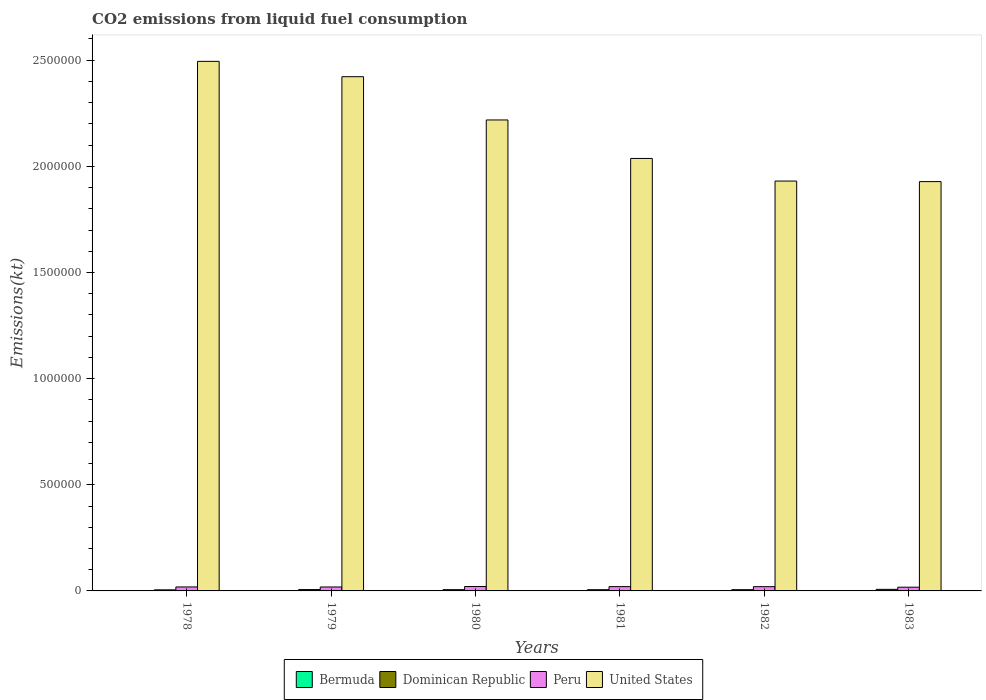How many groups of bars are there?
Offer a very short reply. 6. Are the number of bars per tick equal to the number of legend labels?
Keep it short and to the point. Yes. Are the number of bars on each tick of the X-axis equal?
Give a very brief answer. Yes. How many bars are there on the 2nd tick from the right?
Provide a short and direct response. 4. What is the amount of CO2 emitted in Dominican Republic in 1983?
Keep it short and to the point. 7363.34. Across all years, what is the maximum amount of CO2 emitted in United States?
Ensure brevity in your answer.  2.49e+06. Across all years, what is the minimum amount of CO2 emitted in Bermuda?
Offer a terse response. 388.7. In which year was the amount of CO2 emitted in United States maximum?
Make the answer very short. 1978. In which year was the amount of CO2 emitted in Dominican Republic minimum?
Ensure brevity in your answer.  1978. What is the total amount of CO2 emitted in United States in the graph?
Your answer should be very brief. 1.30e+07. What is the difference between the amount of CO2 emitted in Dominican Republic in 1978 and that in 1983?
Offer a very short reply. -2346.88. What is the difference between the amount of CO2 emitted in Dominican Republic in 1978 and the amount of CO2 emitted in Peru in 1980?
Your answer should be very brief. -1.57e+04. What is the average amount of CO2 emitted in Peru per year?
Offer a terse response. 1.93e+04. In the year 1983, what is the difference between the amount of CO2 emitted in Peru and amount of CO2 emitted in Bermuda?
Provide a short and direct response. 1.71e+04. In how many years, is the amount of CO2 emitted in Dominican Republic greater than 1800000 kt?
Offer a very short reply. 0. What is the ratio of the amount of CO2 emitted in Bermuda in 1980 to that in 1983?
Provide a succinct answer. 0.97. Is the amount of CO2 emitted in United States in 1979 less than that in 1981?
Ensure brevity in your answer.  No. What is the difference between the highest and the second highest amount of CO2 emitted in Bermuda?
Your answer should be compact. 11. What is the difference between the highest and the lowest amount of CO2 emitted in United States?
Offer a terse response. 5.66e+05. In how many years, is the amount of CO2 emitted in Peru greater than the average amount of CO2 emitted in Peru taken over all years?
Your answer should be very brief. 3. Is the sum of the amount of CO2 emitted in Peru in 1978 and 1980 greater than the maximum amount of CO2 emitted in Bermuda across all years?
Your response must be concise. Yes. Is it the case that in every year, the sum of the amount of CO2 emitted in Bermuda and amount of CO2 emitted in Peru is greater than the sum of amount of CO2 emitted in United States and amount of CO2 emitted in Dominican Republic?
Your answer should be very brief. Yes. What does the 4th bar from the left in 1983 represents?
Your answer should be very brief. United States. What does the 3rd bar from the right in 1979 represents?
Give a very brief answer. Dominican Republic. How many bars are there?
Give a very brief answer. 24. Does the graph contain any zero values?
Give a very brief answer. No. Does the graph contain grids?
Make the answer very short. No. Where does the legend appear in the graph?
Offer a very short reply. Bottom center. What is the title of the graph?
Offer a very short reply. CO2 emissions from liquid fuel consumption. Does "West Bank and Gaza" appear as one of the legend labels in the graph?
Give a very brief answer. No. What is the label or title of the X-axis?
Offer a very short reply. Years. What is the label or title of the Y-axis?
Your response must be concise. Emissions(kt). What is the Emissions(kt) in Bermuda in 1978?
Ensure brevity in your answer.  425.37. What is the Emissions(kt) of Dominican Republic in 1978?
Make the answer very short. 5016.46. What is the Emissions(kt) in Peru in 1978?
Provide a short and direct response. 1.87e+04. What is the Emissions(kt) of United States in 1978?
Ensure brevity in your answer.  2.49e+06. What is the Emissions(kt) of Bermuda in 1979?
Your response must be concise. 462.04. What is the Emissions(kt) in Dominican Republic in 1979?
Your answer should be compact. 6365.91. What is the Emissions(kt) of Peru in 1979?
Offer a terse response. 1.86e+04. What is the Emissions(kt) in United States in 1979?
Your answer should be very brief. 2.42e+06. What is the Emissions(kt) of Bermuda in 1980?
Your answer should be very brief. 436.37. What is the Emissions(kt) in Dominican Republic in 1980?
Make the answer very short. 5951.54. What is the Emissions(kt) in Peru in 1980?
Give a very brief answer. 2.07e+04. What is the Emissions(kt) of United States in 1980?
Give a very brief answer. 2.22e+06. What is the Emissions(kt) of Bermuda in 1981?
Provide a succinct answer. 388.7. What is the Emissions(kt) of Dominican Republic in 1981?
Your answer should be very brief. 5694.85. What is the Emissions(kt) of Peru in 1981?
Ensure brevity in your answer.  2.02e+04. What is the Emissions(kt) of United States in 1981?
Provide a succinct answer. 2.04e+06. What is the Emissions(kt) of Bermuda in 1982?
Offer a very short reply. 396.04. What is the Emissions(kt) in Dominican Republic in 1982?
Your response must be concise. 5867.2. What is the Emissions(kt) in Peru in 1982?
Give a very brief answer. 2.01e+04. What is the Emissions(kt) of United States in 1982?
Your response must be concise. 1.93e+06. What is the Emissions(kt) in Bermuda in 1983?
Offer a very short reply. 451.04. What is the Emissions(kt) of Dominican Republic in 1983?
Provide a short and direct response. 7363.34. What is the Emissions(kt) of Peru in 1983?
Provide a succinct answer. 1.76e+04. What is the Emissions(kt) in United States in 1983?
Provide a short and direct response. 1.93e+06. Across all years, what is the maximum Emissions(kt) in Bermuda?
Make the answer very short. 462.04. Across all years, what is the maximum Emissions(kt) of Dominican Republic?
Give a very brief answer. 7363.34. Across all years, what is the maximum Emissions(kt) in Peru?
Your response must be concise. 2.07e+04. Across all years, what is the maximum Emissions(kt) in United States?
Your answer should be very brief. 2.49e+06. Across all years, what is the minimum Emissions(kt) in Bermuda?
Your answer should be very brief. 388.7. Across all years, what is the minimum Emissions(kt) of Dominican Republic?
Offer a very short reply. 5016.46. Across all years, what is the minimum Emissions(kt) of Peru?
Ensure brevity in your answer.  1.76e+04. Across all years, what is the minimum Emissions(kt) of United States?
Your answer should be compact. 1.93e+06. What is the total Emissions(kt) of Bermuda in the graph?
Your answer should be compact. 2559.57. What is the total Emissions(kt) in Dominican Republic in the graph?
Make the answer very short. 3.63e+04. What is the total Emissions(kt) of Peru in the graph?
Your response must be concise. 1.16e+05. What is the total Emissions(kt) in United States in the graph?
Make the answer very short. 1.30e+07. What is the difference between the Emissions(kt) of Bermuda in 1978 and that in 1979?
Offer a very short reply. -36.67. What is the difference between the Emissions(kt) of Dominican Republic in 1978 and that in 1979?
Your response must be concise. -1349.46. What is the difference between the Emissions(kt) in Peru in 1978 and that in 1979?
Give a very brief answer. 172.35. What is the difference between the Emissions(kt) in United States in 1978 and that in 1979?
Provide a short and direct response. 7.23e+04. What is the difference between the Emissions(kt) in Bermuda in 1978 and that in 1980?
Offer a very short reply. -11. What is the difference between the Emissions(kt) in Dominican Republic in 1978 and that in 1980?
Make the answer very short. -935.09. What is the difference between the Emissions(kt) of Peru in 1978 and that in 1980?
Make the answer very short. -1972.85. What is the difference between the Emissions(kt) of United States in 1978 and that in 1980?
Ensure brevity in your answer.  2.76e+05. What is the difference between the Emissions(kt) of Bermuda in 1978 and that in 1981?
Provide a succinct answer. 36.67. What is the difference between the Emissions(kt) of Dominican Republic in 1978 and that in 1981?
Provide a short and direct response. -678.39. What is the difference between the Emissions(kt) of Peru in 1978 and that in 1981?
Keep it short and to the point. -1507.14. What is the difference between the Emissions(kt) of United States in 1978 and that in 1981?
Give a very brief answer. 4.57e+05. What is the difference between the Emissions(kt) in Bermuda in 1978 and that in 1982?
Provide a succinct answer. 29.34. What is the difference between the Emissions(kt) in Dominican Republic in 1978 and that in 1982?
Offer a terse response. -850.74. What is the difference between the Emissions(kt) of Peru in 1978 and that in 1982?
Your response must be concise. -1345.79. What is the difference between the Emissions(kt) of United States in 1978 and that in 1982?
Offer a very short reply. 5.64e+05. What is the difference between the Emissions(kt) of Bermuda in 1978 and that in 1983?
Provide a short and direct response. -25.67. What is the difference between the Emissions(kt) in Dominican Republic in 1978 and that in 1983?
Your answer should be compact. -2346.88. What is the difference between the Emissions(kt) in Peru in 1978 and that in 1983?
Your answer should be compact. 1166.11. What is the difference between the Emissions(kt) of United States in 1978 and that in 1983?
Provide a succinct answer. 5.66e+05. What is the difference between the Emissions(kt) in Bermuda in 1979 and that in 1980?
Keep it short and to the point. 25.67. What is the difference between the Emissions(kt) of Dominican Republic in 1979 and that in 1980?
Offer a very short reply. 414.37. What is the difference between the Emissions(kt) of Peru in 1979 and that in 1980?
Provide a succinct answer. -2145.2. What is the difference between the Emissions(kt) of United States in 1979 and that in 1980?
Ensure brevity in your answer.  2.04e+05. What is the difference between the Emissions(kt) in Bermuda in 1979 and that in 1981?
Keep it short and to the point. 73.34. What is the difference between the Emissions(kt) of Dominican Republic in 1979 and that in 1981?
Keep it short and to the point. 671.06. What is the difference between the Emissions(kt) of Peru in 1979 and that in 1981?
Make the answer very short. -1679.49. What is the difference between the Emissions(kt) of United States in 1979 and that in 1981?
Offer a very short reply. 3.85e+05. What is the difference between the Emissions(kt) in Bermuda in 1979 and that in 1982?
Offer a terse response. 66.01. What is the difference between the Emissions(kt) of Dominican Republic in 1979 and that in 1982?
Your answer should be very brief. 498.71. What is the difference between the Emissions(kt) in Peru in 1979 and that in 1982?
Ensure brevity in your answer.  -1518.14. What is the difference between the Emissions(kt) of United States in 1979 and that in 1982?
Your answer should be very brief. 4.92e+05. What is the difference between the Emissions(kt) of Bermuda in 1979 and that in 1983?
Offer a terse response. 11. What is the difference between the Emissions(kt) in Dominican Republic in 1979 and that in 1983?
Give a very brief answer. -997.42. What is the difference between the Emissions(kt) of Peru in 1979 and that in 1983?
Provide a succinct answer. 993.76. What is the difference between the Emissions(kt) of United States in 1979 and that in 1983?
Your response must be concise. 4.94e+05. What is the difference between the Emissions(kt) in Bermuda in 1980 and that in 1981?
Provide a succinct answer. 47.67. What is the difference between the Emissions(kt) in Dominican Republic in 1980 and that in 1981?
Your response must be concise. 256.69. What is the difference between the Emissions(kt) in Peru in 1980 and that in 1981?
Provide a succinct answer. 465.71. What is the difference between the Emissions(kt) in United States in 1980 and that in 1981?
Offer a terse response. 1.81e+05. What is the difference between the Emissions(kt) in Bermuda in 1980 and that in 1982?
Your response must be concise. 40.34. What is the difference between the Emissions(kt) of Dominican Republic in 1980 and that in 1982?
Ensure brevity in your answer.  84.34. What is the difference between the Emissions(kt) in Peru in 1980 and that in 1982?
Give a very brief answer. 627.06. What is the difference between the Emissions(kt) of United States in 1980 and that in 1982?
Your response must be concise. 2.88e+05. What is the difference between the Emissions(kt) in Bermuda in 1980 and that in 1983?
Ensure brevity in your answer.  -14.67. What is the difference between the Emissions(kt) of Dominican Republic in 1980 and that in 1983?
Ensure brevity in your answer.  -1411.8. What is the difference between the Emissions(kt) of Peru in 1980 and that in 1983?
Offer a very short reply. 3138.95. What is the difference between the Emissions(kt) in United States in 1980 and that in 1983?
Your response must be concise. 2.90e+05. What is the difference between the Emissions(kt) in Bermuda in 1981 and that in 1982?
Offer a very short reply. -7.33. What is the difference between the Emissions(kt) in Dominican Republic in 1981 and that in 1982?
Your response must be concise. -172.35. What is the difference between the Emissions(kt) of Peru in 1981 and that in 1982?
Your response must be concise. 161.35. What is the difference between the Emissions(kt) of United States in 1981 and that in 1982?
Make the answer very short. 1.07e+05. What is the difference between the Emissions(kt) of Bermuda in 1981 and that in 1983?
Offer a very short reply. -62.34. What is the difference between the Emissions(kt) of Dominican Republic in 1981 and that in 1983?
Your answer should be very brief. -1668.48. What is the difference between the Emissions(kt) of Peru in 1981 and that in 1983?
Make the answer very short. 2673.24. What is the difference between the Emissions(kt) of United States in 1981 and that in 1983?
Your response must be concise. 1.09e+05. What is the difference between the Emissions(kt) in Bermuda in 1982 and that in 1983?
Provide a short and direct response. -55.01. What is the difference between the Emissions(kt) of Dominican Republic in 1982 and that in 1983?
Ensure brevity in your answer.  -1496.14. What is the difference between the Emissions(kt) in Peru in 1982 and that in 1983?
Make the answer very short. 2511.89. What is the difference between the Emissions(kt) in United States in 1982 and that in 1983?
Provide a succinct answer. 2511.89. What is the difference between the Emissions(kt) in Bermuda in 1978 and the Emissions(kt) in Dominican Republic in 1979?
Your answer should be very brief. -5940.54. What is the difference between the Emissions(kt) in Bermuda in 1978 and the Emissions(kt) in Peru in 1979?
Provide a succinct answer. -1.81e+04. What is the difference between the Emissions(kt) of Bermuda in 1978 and the Emissions(kt) of United States in 1979?
Your response must be concise. -2.42e+06. What is the difference between the Emissions(kt) in Dominican Republic in 1978 and the Emissions(kt) in Peru in 1979?
Keep it short and to the point. -1.36e+04. What is the difference between the Emissions(kt) of Dominican Republic in 1978 and the Emissions(kt) of United States in 1979?
Ensure brevity in your answer.  -2.42e+06. What is the difference between the Emissions(kt) of Peru in 1978 and the Emissions(kt) of United States in 1979?
Make the answer very short. -2.40e+06. What is the difference between the Emissions(kt) of Bermuda in 1978 and the Emissions(kt) of Dominican Republic in 1980?
Offer a terse response. -5526.17. What is the difference between the Emissions(kt) of Bermuda in 1978 and the Emissions(kt) of Peru in 1980?
Your answer should be compact. -2.03e+04. What is the difference between the Emissions(kt) in Bermuda in 1978 and the Emissions(kt) in United States in 1980?
Provide a short and direct response. -2.22e+06. What is the difference between the Emissions(kt) in Dominican Republic in 1978 and the Emissions(kt) in Peru in 1980?
Your response must be concise. -1.57e+04. What is the difference between the Emissions(kt) in Dominican Republic in 1978 and the Emissions(kt) in United States in 1980?
Your answer should be very brief. -2.21e+06. What is the difference between the Emissions(kt) of Peru in 1978 and the Emissions(kt) of United States in 1980?
Make the answer very short. -2.20e+06. What is the difference between the Emissions(kt) in Bermuda in 1978 and the Emissions(kt) in Dominican Republic in 1981?
Provide a short and direct response. -5269.48. What is the difference between the Emissions(kt) of Bermuda in 1978 and the Emissions(kt) of Peru in 1981?
Your response must be concise. -1.98e+04. What is the difference between the Emissions(kt) in Bermuda in 1978 and the Emissions(kt) in United States in 1981?
Your answer should be very brief. -2.04e+06. What is the difference between the Emissions(kt) of Dominican Republic in 1978 and the Emissions(kt) of Peru in 1981?
Your answer should be compact. -1.52e+04. What is the difference between the Emissions(kt) in Dominican Republic in 1978 and the Emissions(kt) in United States in 1981?
Give a very brief answer. -2.03e+06. What is the difference between the Emissions(kt) in Peru in 1978 and the Emissions(kt) in United States in 1981?
Your answer should be compact. -2.02e+06. What is the difference between the Emissions(kt) in Bermuda in 1978 and the Emissions(kt) in Dominican Republic in 1982?
Your response must be concise. -5441.83. What is the difference between the Emissions(kt) in Bermuda in 1978 and the Emissions(kt) in Peru in 1982?
Ensure brevity in your answer.  -1.97e+04. What is the difference between the Emissions(kt) in Bermuda in 1978 and the Emissions(kt) in United States in 1982?
Offer a very short reply. -1.93e+06. What is the difference between the Emissions(kt) of Dominican Republic in 1978 and the Emissions(kt) of Peru in 1982?
Your answer should be very brief. -1.51e+04. What is the difference between the Emissions(kt) of Dominican Republic in 1978 and the Emissions(kt) of United States in 1982?
Keep it short and to the point. -1.93e+06. What is the difference between the Emissions(kt) in Peru in 1978 and the Emissions(kt) in United States in 1982?
Offer a terse response. -1.91e+06. What is the difference between the Emissions(kt) of Bermuda in 1978 and the Emissions(kt) of Dominican Republic in 1983?
Offer a very short reply. -6937.96. What is the difference between the Emissions(kt) of Bermuda in 1978 and the Emissions(kt) of Peru in 1983?
Provide a short and direct response. -1.72e+04. What is the difference between the Emissions(kt) in Bermuda in 1978 and the Emissions(kt) in United States in 1983?
Your response must be concise. -1.93e+06. What is the difference between the Emissions(kt) in Dominican Republic in 1978 and the Emissions(kt) in Peru in 1983?
Your response must be concise. -1.26e+04. What is the difference between the Emissions(kt) in Dominican Republic in 1978 and the Emissions(kt) in United States in 1983?
Your answer should be compact. -1.92e+06. What is the difference between the Emissions(kt) of Peru in 1978 and the Emissions(kt) of United States in 1983?
Give a very brief answer. -1.91e+06. What is the difference between the Emissions(kt) of Bermuda in 1979 and the Emissions(kt) of Dominican Republic in 1980?
Make the answer very short. -5489.5. What is the difference between the Emissions(kt) of Bermuda in 1979 and the Emissions(kt) of Peru in 1980?
Provide a succinct answer. -2.03e+04. What is the difference between the Emissions(kt) in Bermuda in 1979 and the Emissions(kt) in United States in 1980?
Provide a succinct answer. -2.22e+06. What is the difference between the Emissions(kt) of Dominican Republic in 1979 and the Emissions(kt) of Peru in 1980?
Provide a succinct answer. -1.43e+04. What is the difference between the Emissions(kt) of Dominican Republic in 1979 and the Emissions(kt) of United States in 1980?
Offer a very short reply. -2.21e+06. What is the difference between the Emissions(kt) in Peru in 1979 and the Emissions(kt) in United States in 1980?
Give a very brief answer. -2.20e+06. What is the difference between the Emissions(kt) of Bermuda in 1979 and the Emissions(kt) of Dominican Republic in 1981?
Offer a very short reply. -5232.81. What is the difference between the Emissions(kt) of Bermuda in 1979 and the Emissions(kt) of Peru in 1981?
Ensure brevity in your answer.  -1.98e+04. What is the difference between the Emissions(kt) of Bermuda in 1979 and the Emissions(kt) of United States in 1981?
Keep it short and to the point. -2.04e+06. What is the difference between the Emissions(kt) of Dominican Republic in 1979 and the Emissions(kt) of Peru in 1981?
Give a very brief answer. -1.39e+04. What is the difference between the Emissions(kt) in Dominican Republic in 1979 and the Emissions(kt) in United States in 1981?
Your answer should be very brief. -2.03e+06. What is the difference between the Emissions(kt) in Peru in 1979 and the Emissions(kt) in United States in 1981?
Your answer should be compact. -2.02e+06. What is the difference between the Emissions(kt) of Bermuda in 1979 and the Emissions(kt) of Dominican Republic in 1982?
Ensure brevity in your answer.  -5405.16. What is the difference between the Emissions(kt) in Bermuda in 1979 and the Emissions(kt) in Peru in 1982?
Your answer should be compact. -1.96e+04. What is the difference between the Emissions(kt) of Bermuda in 1979 and the Emissions(kt) of United States in 1982?
Your answer should be compact. -1.93e+06. What is the difference between the Emissions(kt) in Dominican Republic in 1979 and the Emissions(kt) in Peru in 1982?
Provide a short and direct response. -1.37e+04. What is the difference between the Emissions(kt) in Dominican Republic in 1979 and the Emissions(kt) in United States in 1982?
Keep it short and to the point. -1.92e+06. What is the difference between the Emissions(kt) of Peru in 1979 and the Emissions(kt) of United States in 1982?
Keep it short and to the point. -1.91e+06. What is the difference between the Emissions(kt) in Bermuda in 1979 and the Emissions(kt) in Dominican Republic in 1983?
Give a very brief answer. -6901.29. What is the difference between the Emissions(kt) in Bermuda in 1979 and the Emissions(kt) in Peru in 1983?
Give a very brief answer. -1.71e+04. What is the difference between the Emissions(kt) of Bermuda in 1979 and the Emissions(kt) of United States in 1983?
Provide a succinct answer. -1.93e+06. What is the difference between the Emissions(kt) of Dominican Republic in 1979 and the Emissions(kt) of Peru in 1983?
Offer a terse response. -1.12e+04. What is the difference between the Emissions(kt) of Dominican Republic in 1979 and the Emissions(kt) of United States in 1983?
Offer a very short reply. -1.92e+06. What is the difference between the Emissions(kt) in Peru in 1979 and the Emissions(kt) in United States in 1983?
Make the answer very short. -1.91e+06. What is the difference between the Emissions(kt) of Bermuda in 1980 and the Emissions(kt) of Dominican Republic in 1981?
Offer a terse response. -5258.48. What is the difference between the Emissions(kt) of Bermuda in 1980 and the Emissions(kt) of Peru in 1981?
Offer a terse response. -1.98e+04. What is the difference between the Emissions(kt) of Bermuda in 1980 and the Emissions(kt) of United States in 1981?
Make the answer very short. -2.04e+06. What is the difference between the Emissions(kt) of Dominican Republic in 1980 and the Emissions(kt) of Peru in 1981?
Provide a succinct answer. -1.43e+04. What is the difference between the Emissions(kt) of Dominican Republic in 1980 and the Emissions(kt) of United States in 1981?
Give a very brief answer. -2.03e+06. What is the difference between the Emissions(kt) in Peru in 1980 and the Emissions(kt) in United States in 1981?
Give a very brief answer. -2.02e+06. What is the difference between the Emissions(kt) in Bermuda in 1980 and the Emissions(kt) in Dominican Republic in 1982?
Make the answer very short. -5430.83. What is the difference between the Emissions(kt) of Bermuda in 1980 and the Emissions(kt) of Peru in 1982?
Give a very brief answer. -1.97e+04. What is the difference between the Emissions(kt) of Bermuda in 1980 and the Emissions(kt) of United States in 1982?
Give a very brief answer. -1.93e+06. What is the difference between the Emissions(kt) in Dominican Republic in 1980 and the Emissions(kt) in Peru in 1982?
Your answer should be very brief. -1.41e+04. What is the difference between the Emissions(kt) of Dominican Republic in 1980 and the Emissions(kt) of United States in 1982?
Your answer should be compact. -1.92e+06. What is the difference between the Emissions(kt) in Peru in 1980 and the Emissions(kt) in United States in 1982?
Keep it short and to the point. -1.91e+06. What is the difference between the Emissions(kt) of Bermuda in 1980 and the Emissions(kt) of Dominican Republic in 1983?
Ensure brevity in your answer.  -6926.96. What is the difference between the Emissions(kt) in Bermuda in 1980 and the Emissions(kt) in Peru in 1983?
Your answer should be very brief. -1.71e+04. What is the difference between the Emissions(kt) in Bermuda in 1980 and the Emissions(kt) in United States in 1983?
Your answer should be compact. -1.93e+06. What is the difference between the Emissions(kt) of Dominican Republic in 1980 and the Emissions(kt) of Peru in 1983?
Ensure brevity in your answer.  -1.16e+04. What is the difference between the Emissions(kt) in Dominican Republic in 1980 and the Emissions(kt) in United States in 1983?
Your answer should be compact. -1.92e+06. What is the difference between the Emissions(kt) of Peru in 1980 and the Emissions(kt) of United States in 1983?
Keep it short and to the point. -1.91e+06. What is the difference between the Emissions(kt) of Bermuda in 1981 and the Emissions(kt) of Dominican Republic in 1982?
Provide a succinct answer. -5478.5. What is the difference between the Emissions(kt) in Bermuda in 1981 and the Emissions(kt) in Peru in 1982?
Offer a terse response. -1.97e+04. What is the difference between the Emissions(kt) of Bermuda in 1981 and the Emissions(kt) of United States in 1982?
Provide a short and direct response. -1.93e+06. What is the difference between the Emissions(kt) in Dominican Republic in 1981 and the Emissions(kt) in Peru in 1982?
Your answer should be compact. -1.44e+04. What is the difference between the Emissions(kt) of Dominican Republic in 1981 and the Emissions(kt) of United States in 1982?
Make the answer very short. -1.93e+06. What is the difference between the Emissions(kt) in Peru in 1981 and the Emissions(kt) in United States in 1982?
Ensure brevity in your answer.  -1.91e+06. What is the difference between the Emissions(kt) in Bermuda in 1981 and the Emissions(kt) in Dominican Republic in 1983?
Your response must be concise. -6974.63. What is the difference between the Emissions(kt) of Bermuda in 1981 and the Emissions(kt) of Peru in 1983?
Ensure brevity in your answer.  -1.72e+04. What is the difference between the Emissions(kt) in Bermuda in 1981 and the Emissions(kt) in United States in 1983?
Keep it short and to the point. -1.93e+06. What is the difference between the Emissions(kt) of Dominican Republic in 1981 and the Emissions(kt) of Peru in 1983?
Provide a short and direct response. -1.19e+04. What is the difference between the Emissions(kt) in Dominican Republic in 1981 and the Emissions(kt) in United States in 1983?
Your response must be concise. -1.92e+06. What is the difference between the Emissions(kt) of Peru in 1981 and the Emissions(kt) of United States in 1983?
Make the answer very short. -1.91e+06. What is the difference between the Emissions(kt) in Bermuda in 1982 and the Emissions(kt) in Dominican Republic in 1983?
Your answer should be compact. -6967.3. What is the difference between the Emissions(kt) in Bermuda in 1982 and the Emissions(kt) in Peru in 1983?
Provide a short and direct response. -1.72e+04. What is the difference between the Emissions(kt) of Bermuda in 1982 and the Emissions(kt) of United States in 1983?
Provide a succinct answer. -1.93e+06. What is the difference between the Emissions(kt) of Dominican Republic in 1982 and the Emissions(kt) of Peru in 1983?
Ensure brevity in your answer.  -1.17e+04. What is the difference between the Emissions(kt) in Dominican Republic in 1982 and the Emissions(kt) in United States in 1983?
Your answer should be very brief. -1.92e+06. What is the difference between the Emissions(kt) of Peru in 1982 and the Emissions(kt) of United States in 1983?
Offer a terse response. -1.91e+06. What is the average Emissions(kt) in Bermuda per year?
Your answer should be compact. 426.59. What is the average Emissions(kt) in Dominican Republic per year?
Offer a terse response. 6043.22. What is the average Emissions(kt) in Peru per year?
Offer a terse response. 1.93e+04. What is the average Emissions(kt) of United States per year?
Offer a terse response. 2.17e+06. In the year 1978, what is the difference between the Emissions(kt) in Bermuda and Emissions(kt) in Dominican Republic?
Offer a terse response. -4591.08. In the year 1978, what is the difference between the Emissions(kt) of Bermuda and Emissions(kt) of Peru?
Offer a very short reply. -1.83e+04. In the year 1978, what is the difference between the Emissions(kt) in Bermuda and Emissions(kt) in United States?
Provide a succinct answer. -2.49e+06. In the year 1978, what is the difference between the Emissions(kt) in Dominican Republic and Emissions(kt) in Peru?
Provide a succinct answer. -1.37e+04. In the year 1978, what is the difference between the Emissions(kt) of Dominican Republic and Emissions(kt) of United States?
Provide a short and direct response. -2.49e+06. In the year 1978, what is the difference between the Emissions(kt) of Peru and Emissions(kt) of United States?
Give a very brief answer. -2.48e+06. In the year 1979, what is the difference between the Emissions(kt) of Bermuda and Emissions(kt) of Dominican Republic?
Offer a terse response. -5903.87. In the year 1979, what is the difference between the Emissions(kt) in Bermuda and Emissions(kt) in Peru?
Your response must be concise. -1.81e+04. In the year 1979, what is the difference between the Emissions(kt) in Bermuda and Emissions(kt) in United States?
Your response must be concise. -2.42e+06. In the year 1979, what is the difference between the Emissions(kt) in Dominican Republic and Emissions(kt) in Peru?
Your response must be concise. -1.22e+04. In the year 1979, what is the difference between the Emissions(kt) of Dominican Republic and Emissions(kt) of United States?
Your response must be concise. -2.42e+06. In the year 1979, what is the difference between the Emissions(kt) of Peru and Emissions(kt) of United States?
Provide a short and direct response. -2.40e+06. In the year 1980, what is the difference between the Emissions(kt) in Bermuda and Emissions(kt) in Dominican Republic?
Offer a terse response. -5515.17. In the year 1980, what is the difference between the Emissions(kt) in Bermuda and Emissions(kt) in Peru?
Keep it short and to the point. -2.03e+04. In the year 1980, what is the difference between the Emissions(kt) in Bermuda and Emissions(kt) in United States?
Make the answer very short. -2.22e+06. In the year 1980, what is the difference between the Emissions(kt) of Dominican Republic and Emissions(kt) of Peru?
Offer a terse response. -1.48e+04. In the year 1980, what is the difference between the Emissions(kt) of Dominican Republic and Emissions(kt) of United States?
Give a very brief answer. -2.21e+06. In the year 1980, what is the difference between the Emissions(kt) in Peru and Emissions(kt) in United States?
Provide a short and direct response. -2.20e+06. In the year 1981, what is the difference between the Emissions(kt) in Bermuda and Emissions(kt) in Dominican Republic?
Give a very brief answer. -5306.15. In the year 1981, what is the difference between the Emissions(kt) in Bermuda and Emissions(kt) in Peru?
Ensure brevity in your answer.  -1.99e+04. In the year 1981, what is the difference between the Emissions(kt) of Bermuda and Emissions(kt) of United States?
Provide a short and direct response. -2.04e+06. In the year 1981, what is the difference between the Emissions(kt) in Dominican Republic and Emissions(kt) in Peru?
Ensure brevity in your answer.  -1.46e+04. In the year 1981, what is the difference between the Emissions(kt) in Dominican Republic and Emissions(kt) in United States?
Make the answer very short. -2.03e+06. In the year 1981, what is the difference between the Emissions(kt) of Peru and Emissions(kt) of United States?
Ensure brevity in your answer.  -2.02e+06. In the year 1982, what is the difference between the Emissions(kt) in Bermuda and Emissions(kt) in Dominican Republic?
Give a very brief answer. -5471.16. In the year 1982, what is the difference between the Emissions(kt) of Bermuda and Emissions(kt) of Peru?
Your response must be concise. -1.97e+04. In the year 1982, what is the difference between the Emissions(kt) of Bermuda and Emissions(kt) of United States?
Offer a very short reply. -1.93e+06. In the year 1982, what is the difference between the Emissions(kt) in Dominican Republic and Emissions(kt) in Peru?
Offer a terse response. -1.42e+04. In the year 1982, what is the difference between the Emissions(kt) in Dominican Republic and Emissions(kt) in United States?
Give a very brief answer. -1.92e+06. In the year 1982, what is the difference between the Emissions(kt) in Peru and Emissions(kt) in United States?
Provide a short and direct response. -1.91e+06. In the year 1983, what is the difference between the Emissions(kt) of Bermuda and Emissions(kt) of Dominican Republic?
Provide a short and direct response. -6912.3. In the year 1983, what is the difference between the Emissions(kt) of Bermuda and Emissions(kt) of Peru?
Your response must be concise. -1.71e+04. In the year 1983, what is the difference between the Emissions(kt) in Bermuda and Emissions(kt) in United States?
Your response must be concise. -1.93e+06. In the year 1983, what is the difference between the Emissions(kt) of Dominican Republic and Emissions(kt) of Peru?
Give a very brief answer. -1.02e+04. In the year 1983, what is the difference between the Emissions(kt) in Dominican Republic and Emissions(kt) in United States?
Give a very brief answer. -1.92e+06. In the year 1983, what is the difference between the Emissions(kt) in Peru and Emissions(kt) in United States?
Make the answer very short. -1.91e+06. What is the ratio of the Emissions(kt) in Bermuda in 1978 to that in 1979?
Provide a succinct answer. 0.92. What is the ratio of the Emissions(kt) in Dominican Republic in 1978 to that in 1979?
Give a very brief answer. 0.79. What is the ratio of the Emissions(kt) in Peru in 1978 to that in 1979?
Ensure brevity in your answer.  1.01. What is the ratio of the Emissions(kt) in United States in 1978 to that in 1979?
Your answer should be very brief. 1.03. What is the ratio of the Emissions(kt) of Bermuda in 1978 to that in 1980?
Make the answer very short. 0.97. What is the ratio of the Emissions(kt) in Dominican Republic in 1978 to that in 1980?
Offer a terse response. 0.84. What is the ratio of the Emissions(kt) in Peru in 1978 to that in 1980?
Ensure brevity in your answer.  0.9. What is the ratio of the Emissions(kt) of United States in 1978 to that in 1980?
Provide a succinct answer. 1.12. What is the ratio of the Emissions(kt) in Bermuda in 1978 to that in 1981?
Provide a short and direct response. 1.09. What is the ratio of the Emissions(kt) in Dominican Republic in 1978 to that in 1981?
Offer a terse response. 0.88. What is the ratio of the Emissions(kt) of Peru in 1978 to that in 1981?
Give a very brief answer. 0.93. What is the ratio of the Emissions(kt) in United States in 1978 to that in 1981?
Make the answer very short. 1.22. What is the ratio of the Emissions(kt) of Bermuda in 1978 to that in 1982?
Your answer should be very brief. 1.07. What is the ratio of the Emissions(kt) of Dominican Republic in 1978 to that in 1982?
Your answer should be very brief. 0.85. What is the ratio of the Emissions(kt) of Peru in 1978 to that in 1982?
Give a very brief answer. 0.93. What is the ratio of the Emissions(kt) of United States in 1978 to that in 1982?
Make the answer very short. 1.29. What is the ratio of the Emissions(kt) in Bermuda in 1978 to that in 1983?
Your answer should be compact. 0.94. What is the ratio of the Emissions(kt) in Dominican Republic in 1978 to that in 1983?
Ensure brevity in your answer.  0.68. What is the ratio of the Emissions(kt) in Peru in 1978 to that in 1983?
Keep it short and to the point. 1.07. What is the ratio of the Emissions(kt) in United States in 1978 to that in 1983?
Your response must be concise. 1.29. What is the ratio of the Emissions(kt) in Bermuda in 1979 to that in 1980?
Give a very brief answer. 1.06. What is the ratio of the Emissions(kt) in Dominican Republic in 1979 to that in 1980?
Provide a succinct answer. 1.07. What is the ratio of the Emissions(kt) of Peru in 1979 to that in 1980?
Give a very brief answer. 0.9. What is the ratio of the Emissions(kt) of United States in 1979 to that in 1980?
Offer a terse response. 1.09. What is the ratio of the Emissions(kt) of Bermuda in 1979 to that in 1981?
Your response must be concise. 1.19. What is the ratio of the Emissions(kt) in Dominican Republic in 1979 to that in 1981?
Provide a short and direct response. 1.12. What is the ratio of the Emissions(kt) of Peru in 1979 to that in 1981?
Make the answer very short. 0.92. What is the ratio of the Emissions(kt) in United States in 1979 to that in 1981?
Provide a succinct answer. 1.19. What is the ratio of the Emissions(kt) in Bermuda in 1979 to that in 1982?
Keep it short and to the point. 1.17. What is the ratio of the Emissions(kt) in Dominican Republic in 1979 to that in 1982?
Your answer should be very brief. 1.08. What is the ratio of the Emissions(kt) of Peru in 1979 to that in 1982?
Provide a succinct answer. 0.92. What is the ratio of the Emissions(kt) of United States in 1979 to that in 1982?
Your answer should be very brief. 1.25. What is the ratio of the Emissions(kt) of Bermuda in 1979 to that in 1983?
Ensure brevity in your answer.  1.02. What is the ratio of the Emissions(kt) in Dominican Republic in 1979 to that in 1983?
Give a very brief answer. 0.86. What is the ratio of the Emissions(kt) in Peru in 1979 to that in 1983?
Give a very brief answer. 1.06. What is the ratio of the Emissions(kt) in United States in 1979 to that in 1983?
Offer a terse response. 1.26. What is the ratio of the Emissions(kt) in Bermuda in 1980 to that in 1981?
Your response must be concise. 1.12. What is the ratio of the Emissions(kt) in Dominican Republic in 1980 to that in 1981?
Provide a short and direct response. 1.05. What is the ratio of the Emissions(kt) of United States in 1980 to that in 1981?
Provide a short and direct response. 1.09. What is the ratio of the Emissions(kt) in Bermuda in 1980 to that in 1982?
Ensure brevity in your answer.  1.1. What is the ratio of the Emissions(kt) in Dominican Republic in 1980 to that in 1982?
Offer a very short reply. 1.01. What is the ratio of the Emissions(kt) in Peru in 1980 to that in 1982?
Provide a succinct answer. 1.03. What is the ratio of the Emissions(kt) of United States in 1980 to that in 1982?
Provide a short and direct response. 1.15. What is the ratio of the Emissions(kt) of Bermuda in 1980 to that in 1983?
Offer a very short reply. 0.97. What is the ratio of the Emissions(kt) in Dominican Republic in 1980 to that in 1983?
Offer a terse response. 0.81. What is the ratio of the Emissions(kt) in Peru in 1980 to that in 1983?
Ensure brevity in your answer.  1.18. What is the ratio of the Emissions(kt) in United States in 1980 to that in 1983?
Your response must be concise. 1.15. What is the ratio of the Emissions(kt) of Bermuda in 1981 to that in 1982?
Make the answer very short. 0.98. What is the ratio of the Emissions(kt) of Dominican Republic in 1981 to that in 1982?
Provide a succinct answer. 0.97. What is the ratio of the Emissions(kt) of Peru in 1981 to that in 1982?
Your answer should be very brief. 1.01. What is the ratio of the Emissions(kt) in United States in 1981 to that in 1982?
Provide a succinct answer. 1.06. What is the ratio of the Emissions(kt) of Bermuda in 1981 to that in 1983?
Offer a terse response. 0.86. What is the ratio of the Emissions(kt) of Dominican Republic in 1981 to that in 1983?
Your answer should be very brief. 0.77. What is the ratio of the Emissions(kt) of Peru in 1981 to that in 1983?
Your answer should be compact. 1.15. What is the ratio of the Emissions(kt) in United States in 1981 to that in 1983?
Your answer should be very brief. 1.06. What is the ratio of the Emissions(kt) in Bermuda in 1982 to that in 1983?
Ensure brevity in your answer.  0.88. What is the ratio of the Emissions(kt) of Dominican Republic in 1982 to that in 1983?
Ensure brevity in your answer.  0.8. What is the difference between the highest and the second highest Emissions(kt) of Bermuda?
Give a very brief answer. 11. What is the difference between the highest and the second highest Emissions(kt) of Dominican Republic?
Provide a succinct answer. 997.42. What is the difference between the highest and the second highest Emissions(kt) in Peru?
Offer a very short reply. 465.71. What is the difference between the highest and the second highest Emissions(kt) in United States?
Your answer should be very brief. 7.23e+04. What is the difference between the highest and the lowest Emissions(kt) of Bermuda?
Your answer should be very brief. 73.34. What is the difference between the highest and the lowest Emissions(kt) of Dominican Republic?
Your answer should be very brief. 2346.88. What is the difference between the highest and the lowest Emissions(kt) in Peru?
Provide a short and direct response. 3138.95. What is the difference between the highest and the lowest Emissions(kt) in United States?
Your response must be concise. 5.66e+05. 